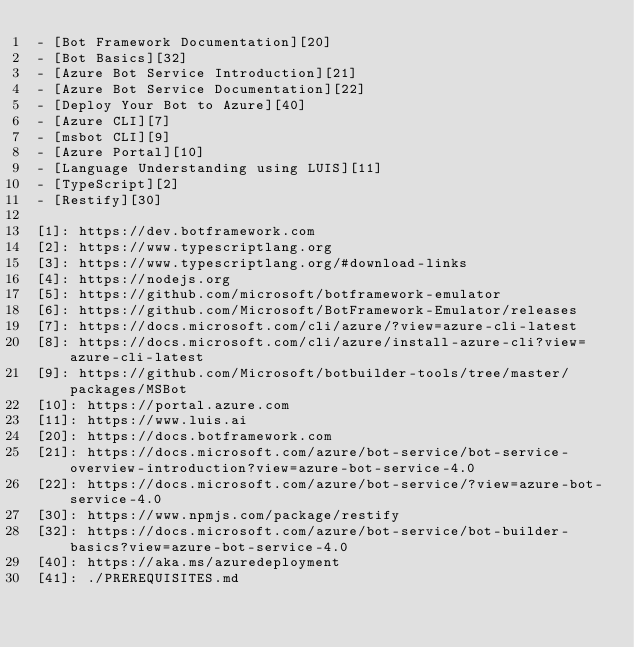<code> <loc_0><loc_0><loc_500><loc_500><_TypeScript_>- [Bot Framework Documentation][20]
- [Bot Basics][32]
- [Azure Bot Service Introduction][21]
- [Azure Bot Service Documentation][22]
- [Deploy Your Bot to Azure][40]
- [Azure CLI][7]
- [msbot CLI][9]
- [Azure Portal][10]
- [Language Understanding using LUIS][11]
- [TypeScript][2]
- [Restify][30]

[1]: https://dev.botframework.com
[2]: https://www.typescriptlang.org
[3]: https://www.typescriptlang.org/#download-links
[4]: https://nodejs.org
[5]: https://github.com/microsoft/botframework-emulator
[6]: https://github.com/Microsoft/BotFramework-Emulator/releases
[7]: https://docs.microsoft.com/cli/azure/?view=azure-cli-latest
[8]: https://docs.microsoft.com/cli/azure/install-azure-cli?view=azure-cli-latest
[9]: https://github.com/Microsoft/botbuilder-tools/tree/master/packages/MSBot
[10]: https://portal.azure.com
[11]: https://www.luis.ai
[20]: https://docs.botframework.com
[21]: https://docs.microsoft.com/azure/bot-service/bot-service-overview-introduction?view=azure-bot-service-4.0
[22]: https://docs.microsoft.com/azure/bot-service/?view=azure-bot-service-4.0
[30]: https://www.npmjs.com/package/restify
[32]: https://docs.microsoft.com/azure/bot-service/bot-builder-basics?view=azure-bot-service-4.0
[40]: https://aka.ms/azuredeployment
[41]: ./PREREQUISITES.md
</code> 